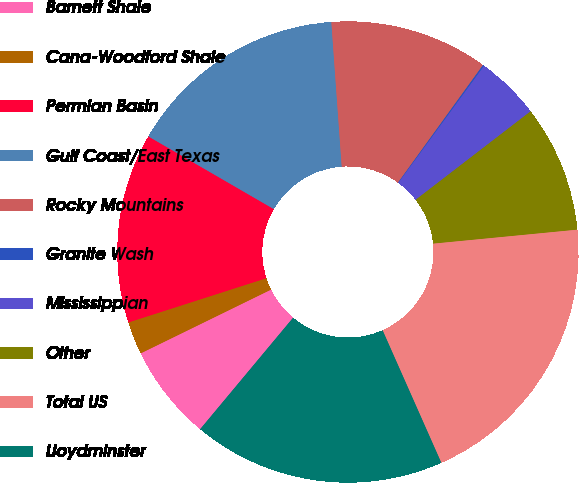Convert chart. <chart><loc_0><loc_0><loc_500><loc_500><pie_chart><fcel>Barnett Shale<fcel>Cana-Woodford Shale<fcel>Permian Basin<fcel>Gulf Coast/East Texas<fcel>Rocky Mountains<fcel>Granite Wash<fcel>Mississippian<fcel>Other<fcel>Total US<fcel>Lloydminster<nl><fcel>6.7%<fcel>2.3%<fcel>13.3%<fcel>15.5%<fcel>11.1%<fcel>0.1%<fcel>4.5%<fcel>8.9%<fcel>19.9%<fcel>17.7%<nl></chart> 